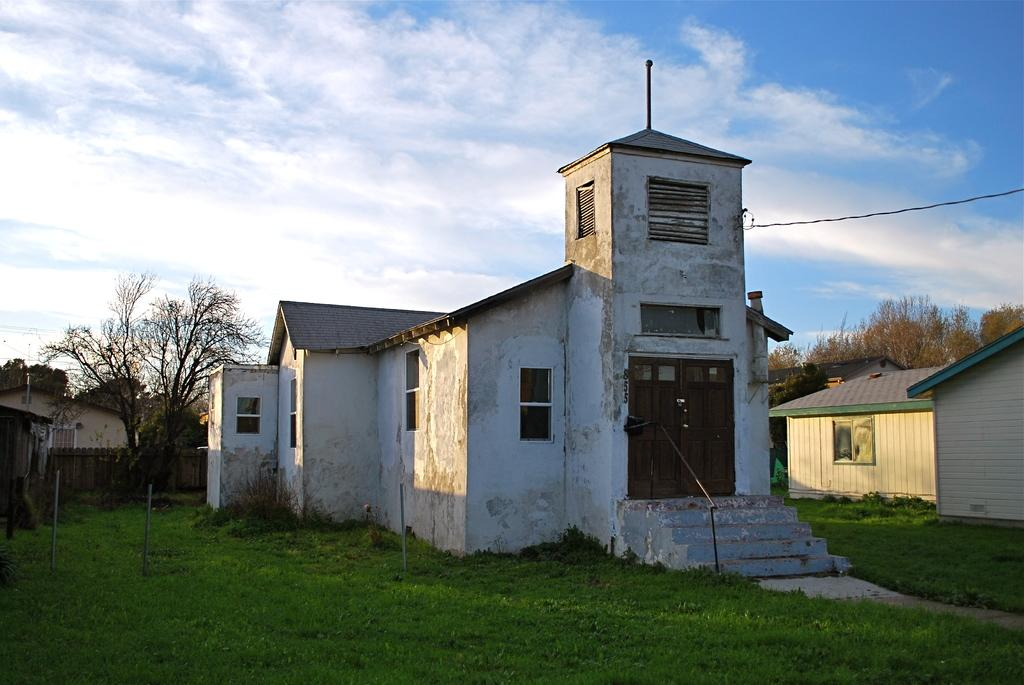What type of vegetation can be seen in the image? There is grass in the image. What structures are present in the image? There are poles, a fence, buildings with windows, and doors in the image. Are there any architectural features in the image? Yes, there are steps in the image. What can be seen in the background of the image? There are trees and the sky visible in the background of the image. What is the condition of the sky in the image? The sky is visible with clouds in the background of the image. How many eyes can be seen on the poles in the image? There are no eyes present on the poles in the image. What is the amount of grass in the image? The amount of grass in the image cannot be quantified, as it is a visual representation. 